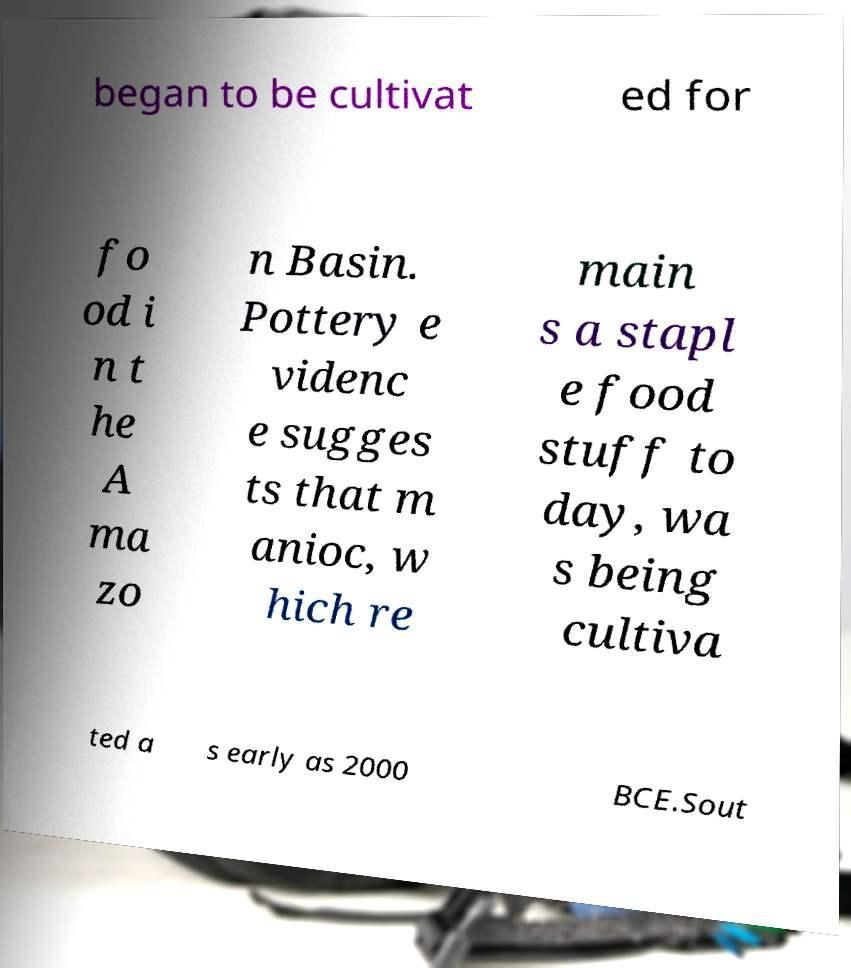Can you read and provide the text displayed in the image?This photo seems to have some interesting text. Can you extract and type it out for me? began to be cultivat ed for fo od i n t he A ma zo n Basin. Pottery e videnc e sugges ts that m anioc, w hich re main s a stapl e food stuff to day, wa s being cultiva ted a s early as 2000 BCE.Sout 